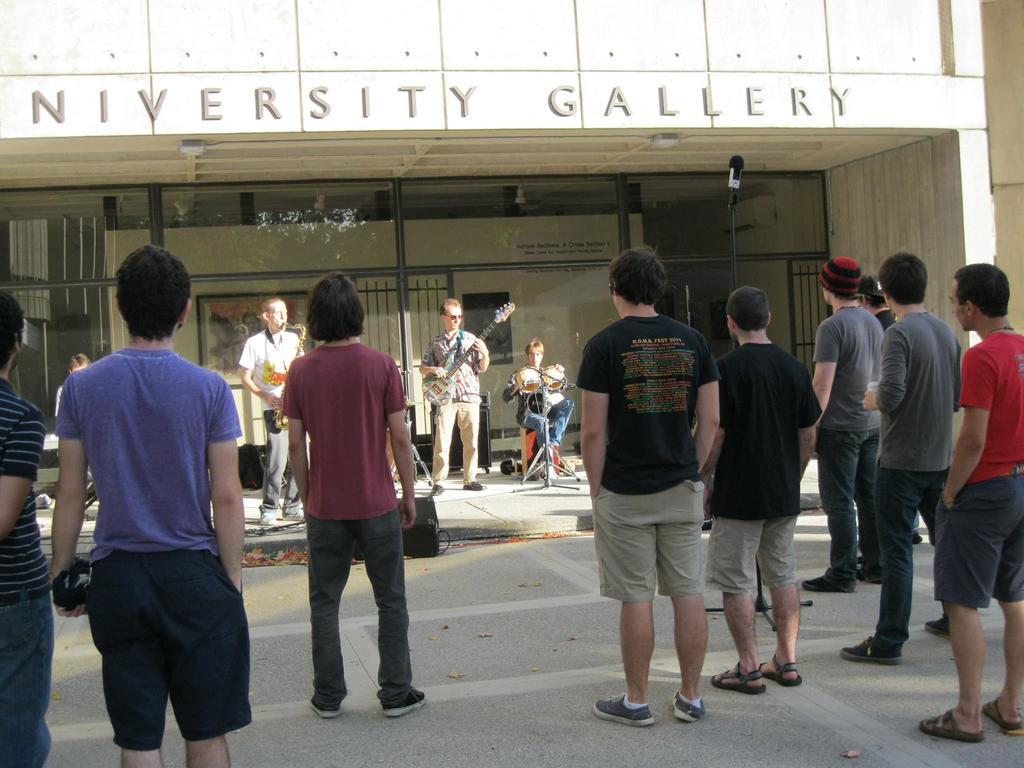Could you give a brief overview of what you see in this image? In this picture we can see a group of people standing on the ground and in front of them we can see some people, musical instruments, posters, rods, fame, stands, walls and some objects. 